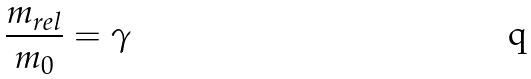<formula> <loc_0><loc_0><loc_500><loc_500>\frac { m _ { r e l } } { m _ { 0 } } = \gamma</formula> 